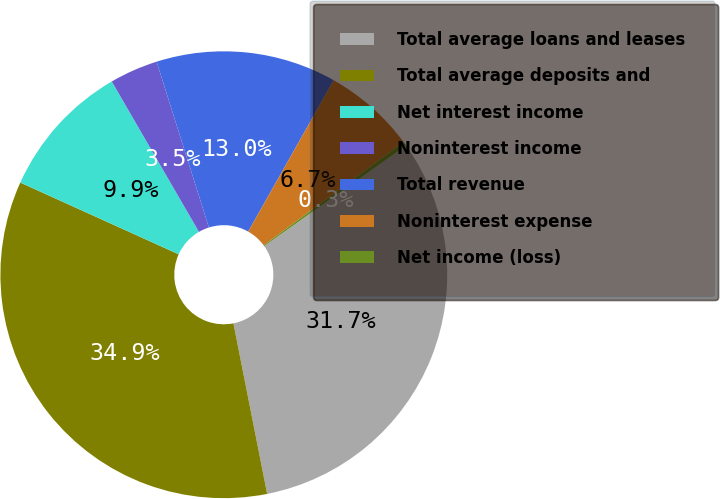Convert chart. <chart><loc_0><loc_0><loc_500><loc_500><pie_chart><fcel>Total average loans and leases<fcel>Total average deposits and<fcel>Net interest income<fcel>Noninterest income<fcel>Total revenue<fcel>Noninterest expense<fcel>Net income (loss)<nl><fcel>31.7%<fcel>34.88%<fcel>9.87%<fcel>3.5%<fcel>13.05%<fcel>6.69%<fcel>0.32%<nl></chart> 